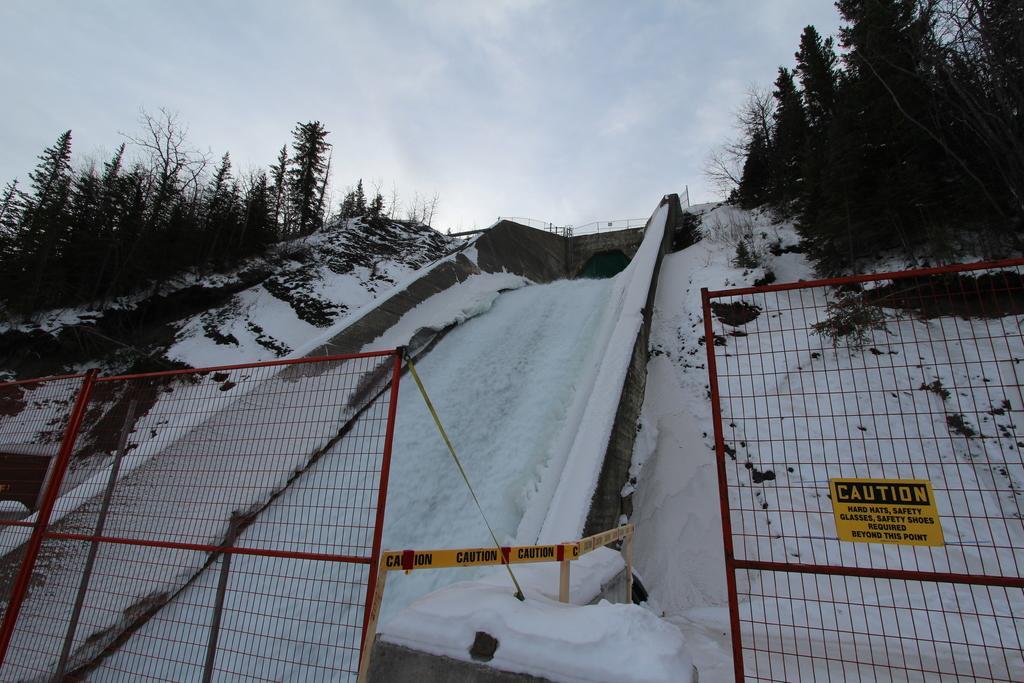In one or two sentences, can you explain what this image depicts? As we can see in the image there is fence, poster, snow and trees. On the top there is sky. 